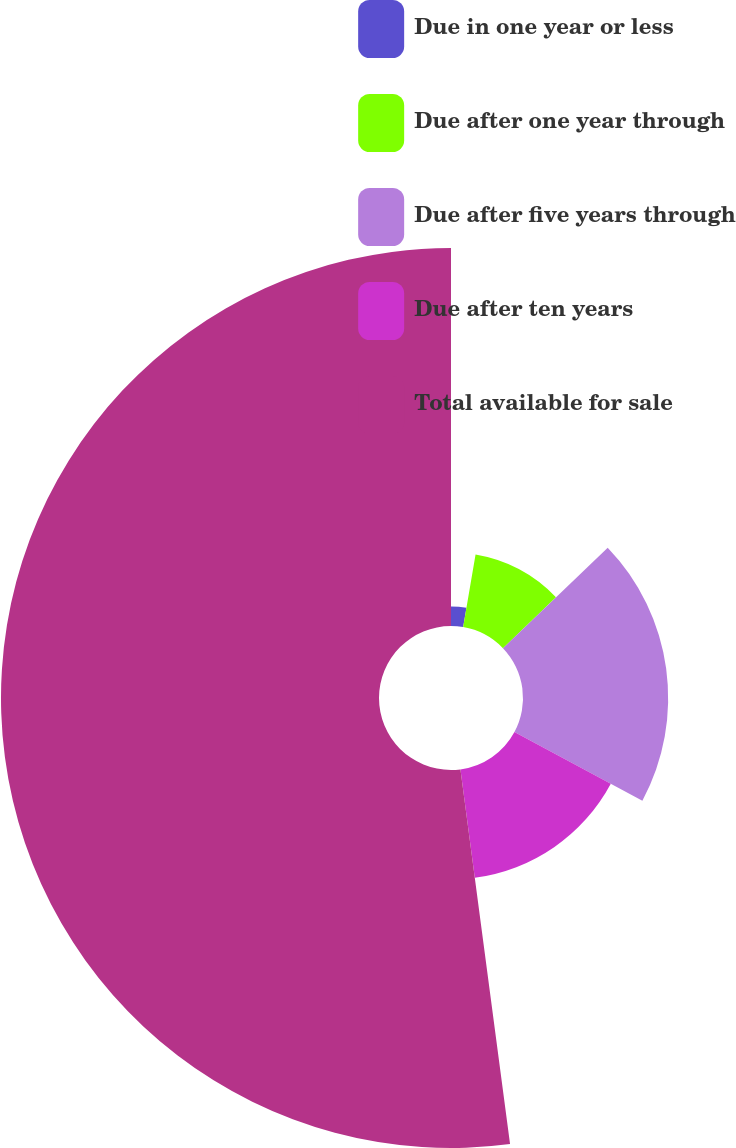<chart> <loc_0><loc_0><loc_500><loc_500><pie_chart><fcel>Due in one year or less<fcel>Due after one year through<fcel>Due after five years through<fcel>Due after ten years<fcel>Total available for sale<nl><fcel>2.7%<fcel>10.13%<fcel>20.01%<fcel>15.07%<fcel>52.1%<nl></chart> 